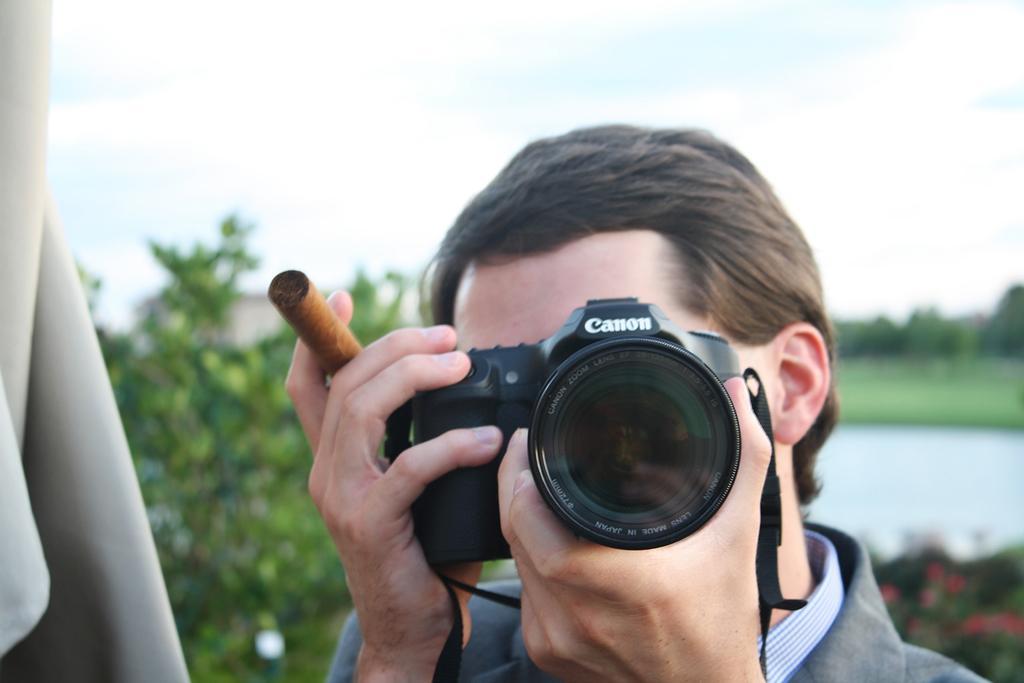In one or two sentences, can you explain what this image depicts? This is the picture of a person holding a camera and a cigar. Behind the person there is a tree and a sky. 